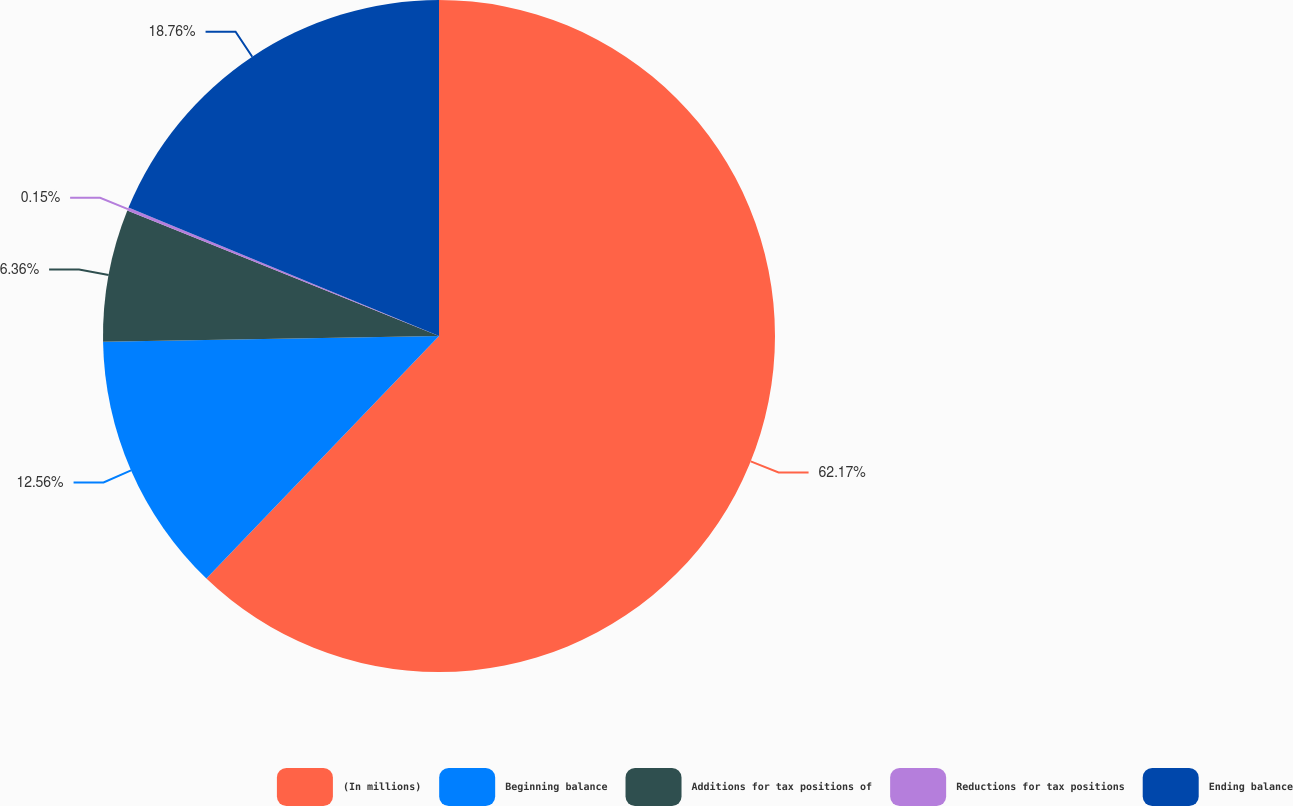Convert chart. <chart><loc_0><loc_0><loc_500><loc_500><pie_chart><fcel>(In millions)<fcel>Beginning balance<fcel>Additions for tax positions of<fcel>Reductions for tax positions<fcel>Ending balance<nl><fcel>62.17%<fcel>12.56%<fcel>6.36%<fcel>0.15%<fcel>18.76%<nl></chart> 